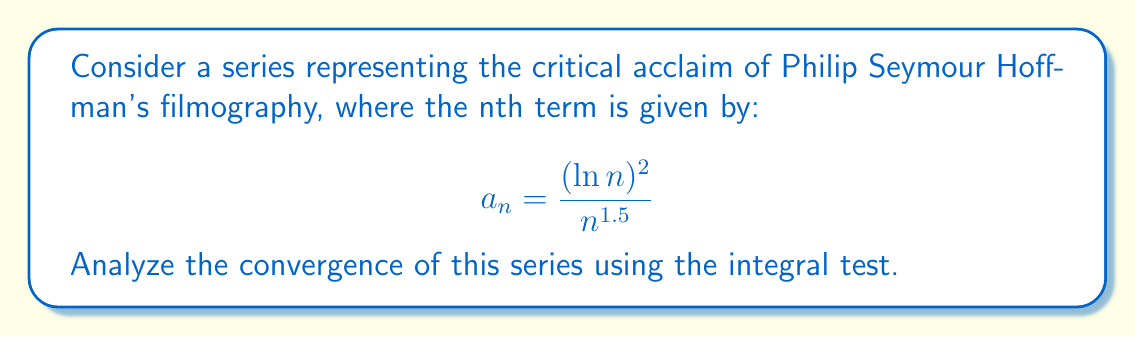Teach me how to tackle this problem. To analyze the convergence of this series using the integral test, we'll follow these steps:

1) First, we need to verify that $a_n$ is positive and decreasing for all $n \geq 2$:
   $a_n = \frac{(\ln n)^2}{n^{1.5}} > 0$ for all $n \geq 2$
   
   To check if it's decreasing, we can differentiate:
   $$\frac{d}{dn}\left(\frac{(\ln n)^2}{n^{1.5}}\right) = \frac{2\ln n}{n^{1.5}} - \frac{3(\ln n)^2}{2n^{2.5}} < 0$$ for $n \geq 3$

2) Now we can apply the integral test. We need to evaluate:
   $$\int_2^{\infty} \frac{(\ln x)^2}{x^{1.5}} dx$$

3) Let $u = \ln x$, then $du = \frac{1}{x}dx$ and $x = e^u$:
   $$\int_{\ln 2}^{\infty} \frac{u^2}{(e^u)^{1.5}} e^u du = \int_{\ln 2}^{\infty} u^2 e^{-0.5u} du$$

4) This integral can be evaluated using integration by parts twice:
   Let $v = u^2$ and $dw = e^{-0.5u}du$
   $$\int_{\ln 2}^{\infty} u^2 e^{-0.5u} du = -2u^2e^{-0.5u}|_{\ln 2}^{\infty} + \int_{\ln 2}^{\infty} 4ue^{-0.5u} du$$
   
   Again, let $v = u$ and $dw = e^{-0.5u}du$
   $$= -2u^2e^{-0.5u}|_{\ln 2}^{\infty} - 8ue^{-0.5u}|_{\ln 2}^{\infty} + \int_{\ln 2}^{\infty} 8e^{-0.5u} du$$
   
   $$= -2u^2e^{-0.5u}|_{\ln 2}^{\infty} - 8ue^{-0.5u}|_{\ln 2}^{\infty} - 16e^{-0.5u}|_{\ln 2}^{\infty}$$

5) Evaluating the limits:
   $$\lim_{u \to \infty} u^2e^{-0.5u} = 0$$
   $$\lim_{u \to \infty} ue^{-0.5u} = 0$$
   $$\lim_{u \to \infty} e^{-0.5u} = 0$$

6) Therefore, the integral simplifies to:
   $$2(\ln 2)^2 \cdot 2^{-0.5} + 8\ln 2 \cdot 2^{-0.5} + 16 \cdot 2^{-0.5} = (2(\ln 2)^2 + 8\ln 2 + 16) \cdot 2^{-0.5}$$

Since this integral converges to a finite value, by the integral test, the original series also converges.
Answer: The series converges. 